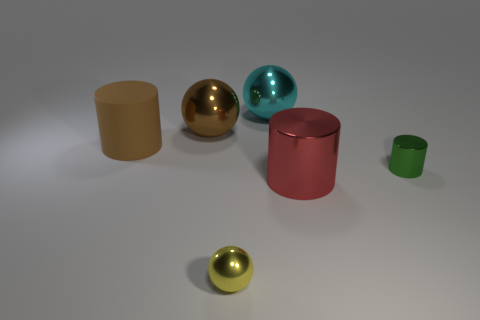Is there anything else that is the same color as the matte thing?
Provide a succinct answer. Yes. There is a large cyan object that is made of the same material as the small sphere; what is its shape?
Your answer should be very brief. Sphere. There is a tiny metal object that is in front of the tiny green metal cylinder that is on the right side of the brown matte thing; how many small metal objects are on the right side of it?
Make the answer very short. 1. The object that is in front of the small green object and behind the yellow sphere has what shape?
Keep it short and to the point. Cylinder. Is the number of large metal balls that are in front of the tiny yellow metallic sphere less than the number of large cylinders?
Your response must be concise. Yes. How many large objects are either blue blocks or rubber things?
Keep it short and to the point. 1. What is the size of the yellow thing?
Your answer should be compact. Small. Is there any other thing that is made of the same material as the small green cylinder?
Provide a short and direct response. Yes. How many metal objects are behind the brown sphere?
Your answer should be compact. 1. What is the size of the green shiny object that is the same shape as the brown matte object?
Provide a succinct answer. Small. 